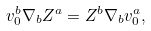Convert formula to latex. <formula><loc_0><loc_0><loc_500><loc_500>v _ { 0 } ^ { b } \nabla _ { b } Z ^ { a } = Z ^ { b } \nabla _ { b } v _ { 0 } ^ { a } ,</formula> 